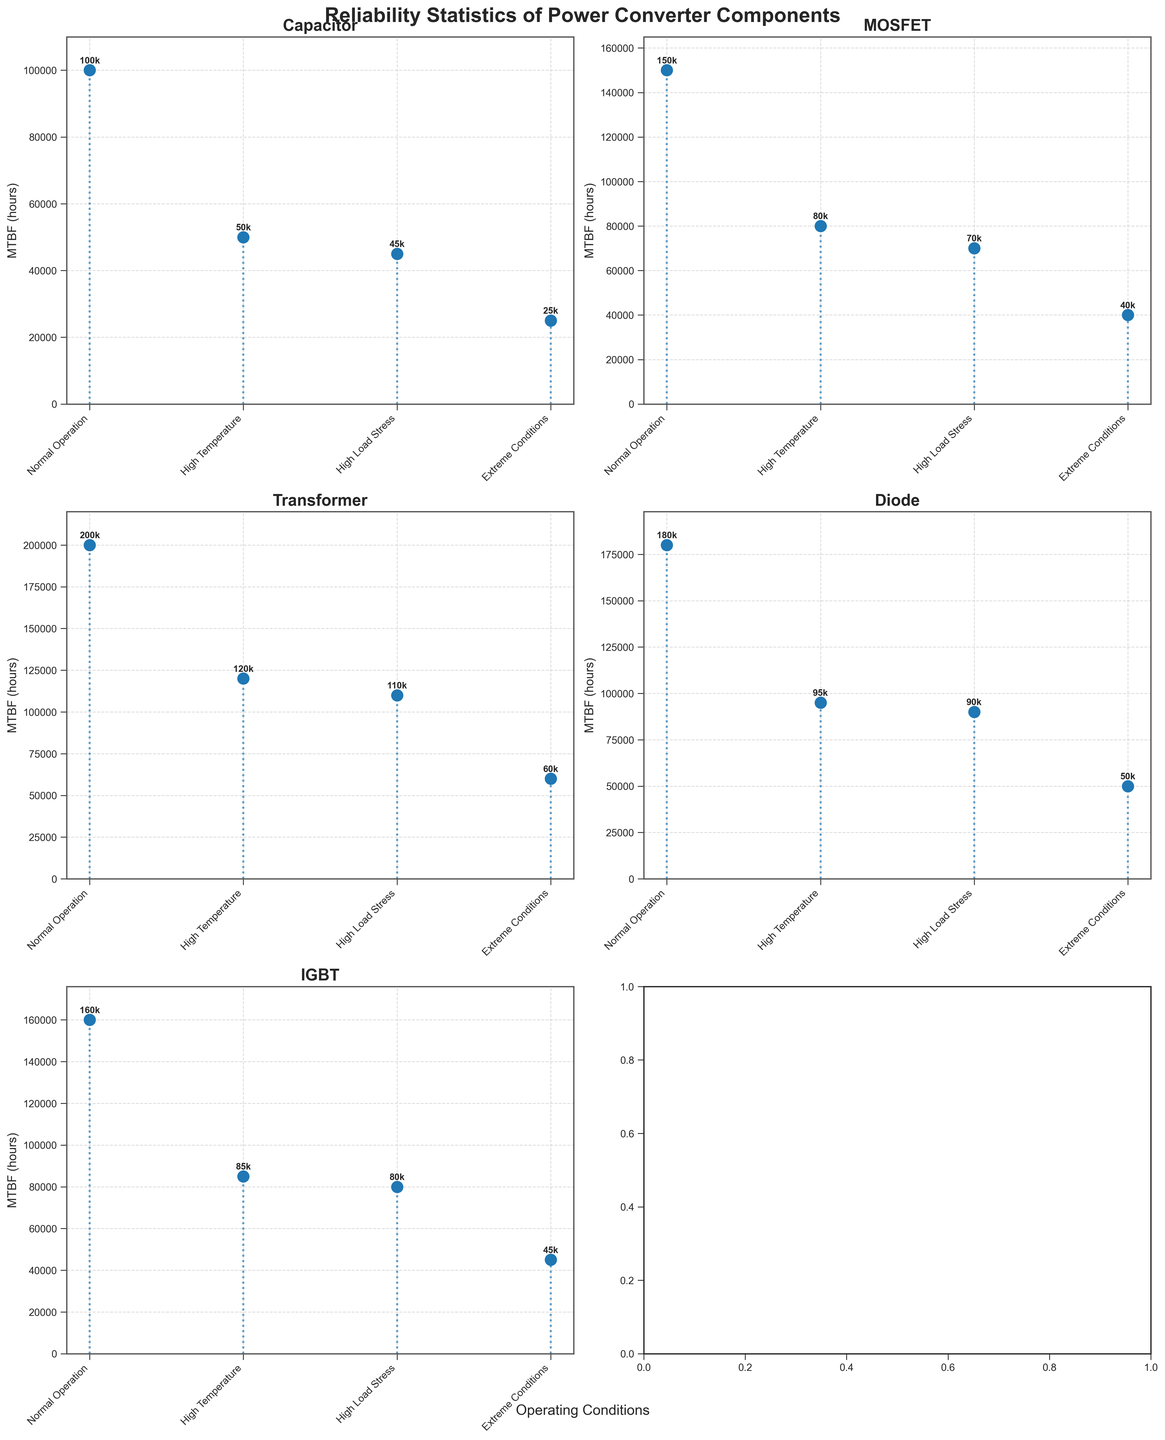How many operating conditions are shown for each component? The figure contains subplots for multiple components, each with four different operating conditions clearly marked on the x-axis: Normal Operation, High Temperature, High Load Stress, and Extreme Conditions.
Answer: Four What is the MTBF of capacitors under extreme conditions? Referencing the subplot for capacitors, the stem plot shows that the Mean Time Between Failures (MTBF) value for capacitors under extreme conditions (85°C, 90% load stress) is 25,000 hours.
Answer: 25,000 hours Which component shows the highest MTBF under normal operation? Examining the MTBF values for normal operation across all subplots reveals that the transformer has the highest MTBF value of 200,000 hours.
Answer: Transformer What is the difference in MTBF between high and extreme conditions for MOSFETs? In the subplot for MOSFETs, the high temperature condition shows an MTBF of 80,000 hours, whereas the extreme conditions show an MTBF of 40,000 hours. To find the difference, subtract 40,000 from 80,000.
Answer: 40,000 hours Which component has the smallest decrease in MTBF when moving from normal operation to high load stress? To find the smallest decrease, we look at each component's MTBF values under normal operation and high load stress: 
Capacitor: 100,000 to 45,000 (decrease of 55,000) 
MOSFET: 150,000 to 70,000 (decrease of 80,000)
Transformer: 200,000 to 110,000 (decrease of 90,000)
Diode: 180,000 to 90,000 (decrease of 90,000)
IGBT: 160,000 to 80,000 (decrease of 80,000)
The capacitor shows the smallest decrease.
Answer: Capacitor What is the average MTBF of diodes under all conditions? To find the average MTBF for diodes, first sum the MTBF values: 180,000 + 95,000 + 90,000 + 50,000 = 415,000. Then divide by the number of conditions, which is 4.
Answer: 103,750 hours Which operating condition generally results in the highest MTBF across all components? Reviewing each subplot, the normal operation condition consistently shows the highest MTBF values across all components, indicating it generally results in the highest reliability.
Answer: Normal Operation By how much does the MTBF of IGBTs decrease when subjected to high temperature compared to normal operation? In the IGBT subplot, the high temperature condition has an MTBF of 85,000 hours, and normal operation has 160,000 hours. The decrease is the difference between these values: 160,000 - 85,000.
Answer: 75,000 hours Under which condition does the capacitor have its MTBF reduced the most? In the capacitor’s subplot, the MTBF under extreme conditions is lowest at 25,000 hours, compared to other conditions. The greatest reduction occurs from normal operation (100,000) to extreme conditions.
Answer: Extreme Conditions 